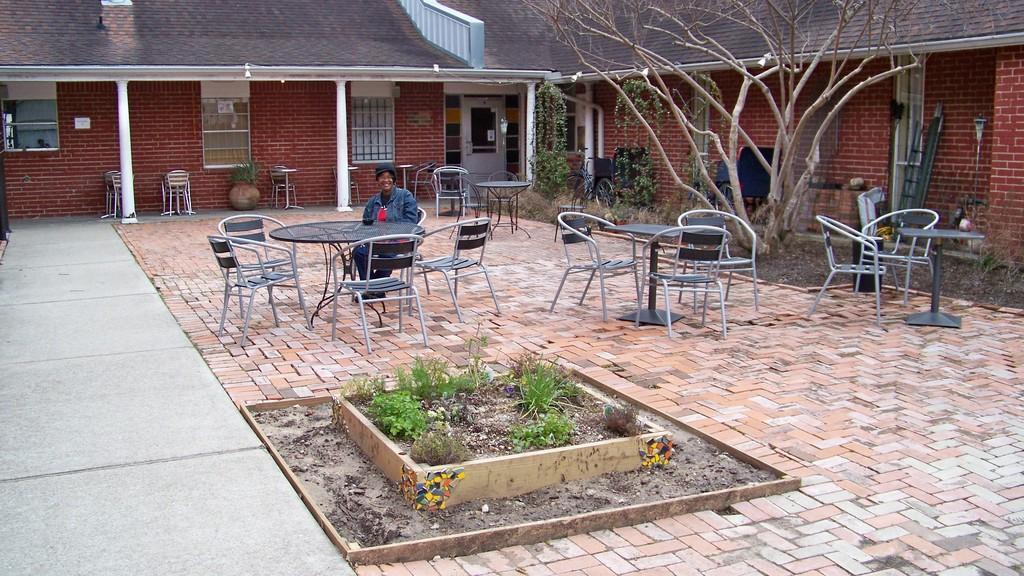How would you summarize this image in a sentence or two? In this image there is a woman standing in the chair and there is a table , plants ,bicycle, ladder , pole , garden type and at the back ground there is a building with some plants and a door. 